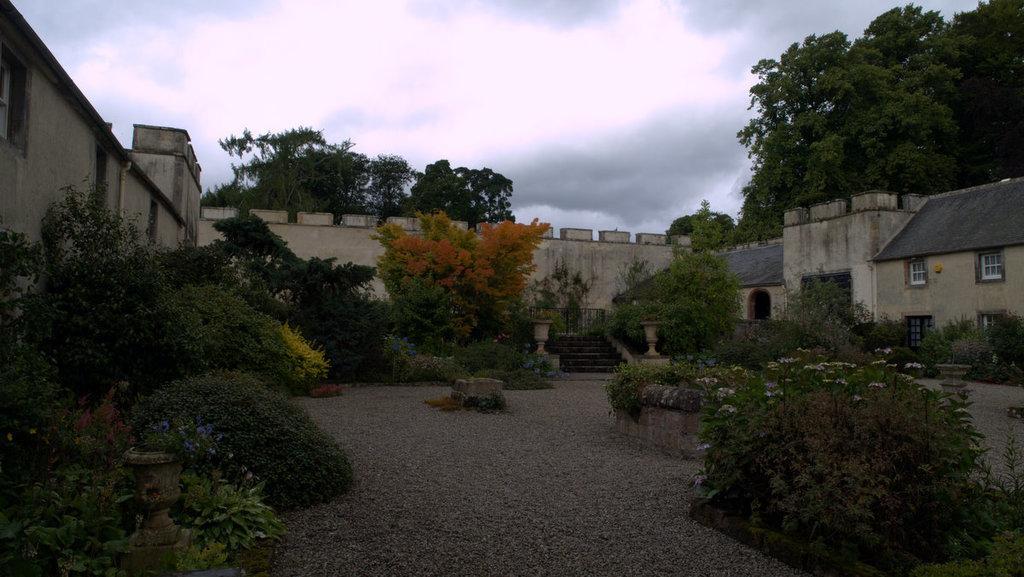Could you give a brief overview of what you see in this image? In this image I can see number of plants and number of trees. On the left side and on the right side of this image I can see few buildings and windows. In the background I can see clouds and the sky. 